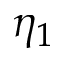Convert formula to latex. <formula><loc_0><loc_0><loc_500><loc_500>\eta _ { 1 }</formula> 